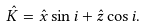<formula> <loc_0><loc_0><loc_500><loc_500>\hat { K } = \hat { x } \sin i + \hat { z } \cos i .</formula> 